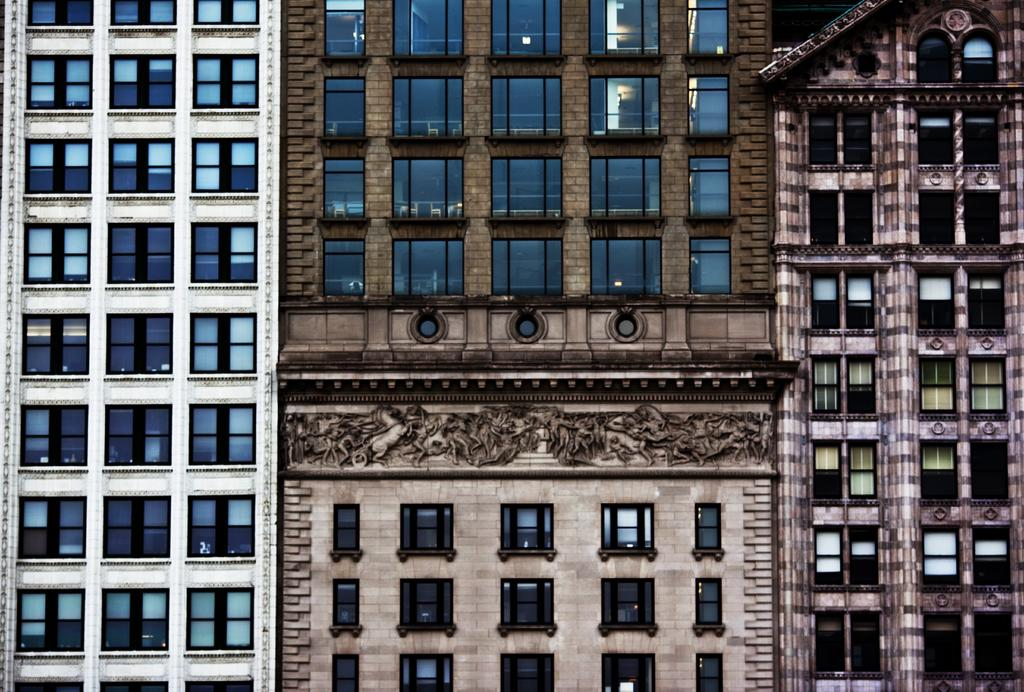What type of structures are visible in the image? There are buildings in the image. What architectural feature can be seen on the buildings? There are windows visible on the buildings. Can you determine the time of day the image was taken? The image was likely taken during the day, as there is sufficient light to see the buildings and windows clearly. Is there a birthday celebration happening in the image? There is no indication of a birthday celebration in the image; it primarily features buildings and windows. 